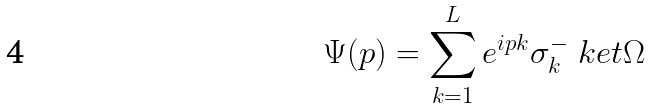Convert formula to latex. <formula><loc_0><loc_0><loc_500><loc_500>\Psi ( p ) = \sum _ { k = 1 } ^ { L } e ^ { i p k } \sigma ^ { - } _ { k } \ k e t { \Omega }</formula> 